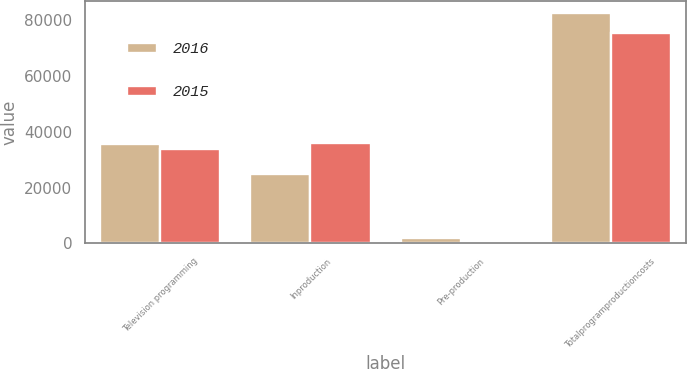Convert chart to OTSL. <chart><loc_0><loc_0><loc_500><loc_500><stacked_bar_chart><ecel><fcel>Television programming<fcel>Inproduction<fcel>Pre-production<fcel>Totalprogramproductioncosts<nl><fcel>2016<fcel>35683<fcel>25062<fcel>1833<fcel>82849<nl><fcel>2015<fcel>33730<fcel>36092<fcel>84<fcel>75546<nl></chart> 